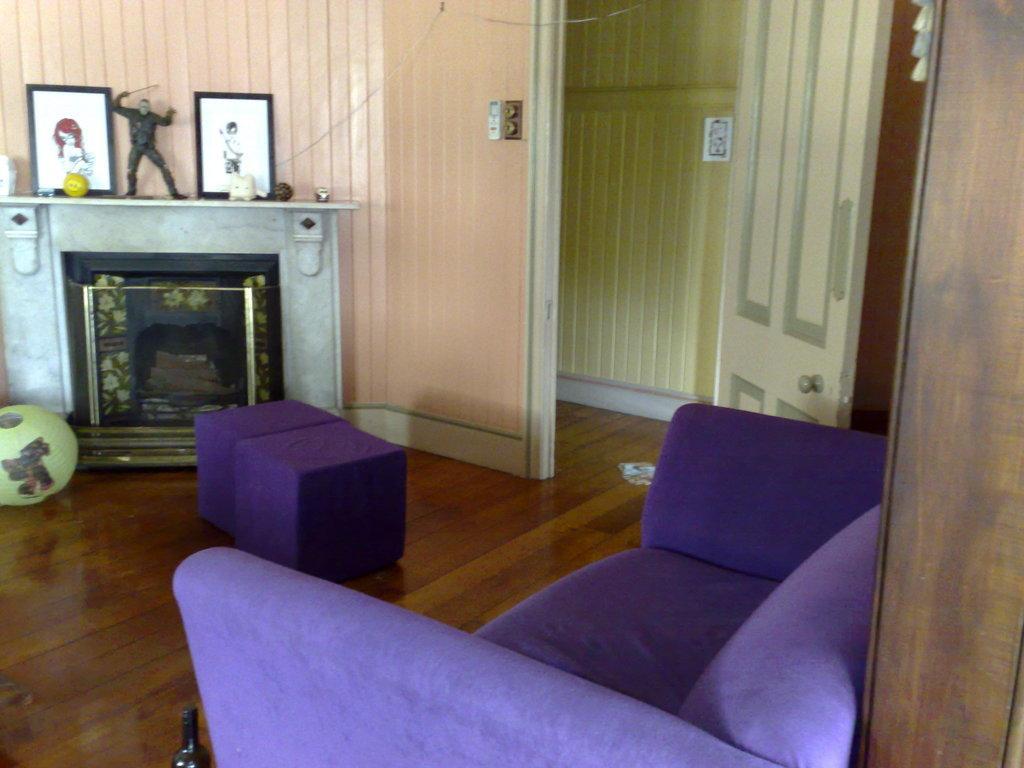Could you give a brief overview of what you see in this image? Here in this picture we can see a chair at the bottom right and besides that we can see at door and at the left side we can see photo frames and there is a doll behind that and here we can see a ball 